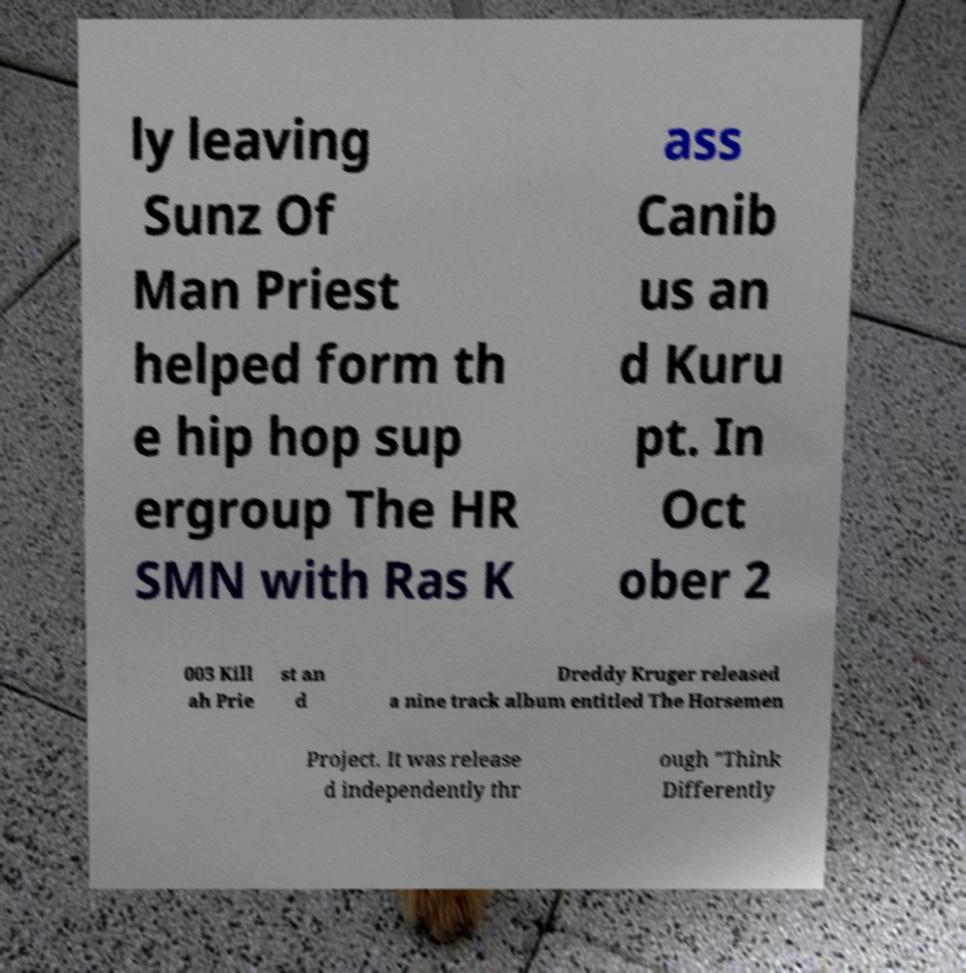Could you assist in decoding the text presented in this image and type it out clearly? ly leaving Sunz Of Man Priest helped form th e hip hop sup ergroup The HR SMN with Ras K ass Canib us an d Kuru pt. In Oct ober 2 003 Kill ah Prie st an d Dreddy Kruger released a nine track album entitled The Horsemen Project. It was release d independently thr ough "Think Differently 